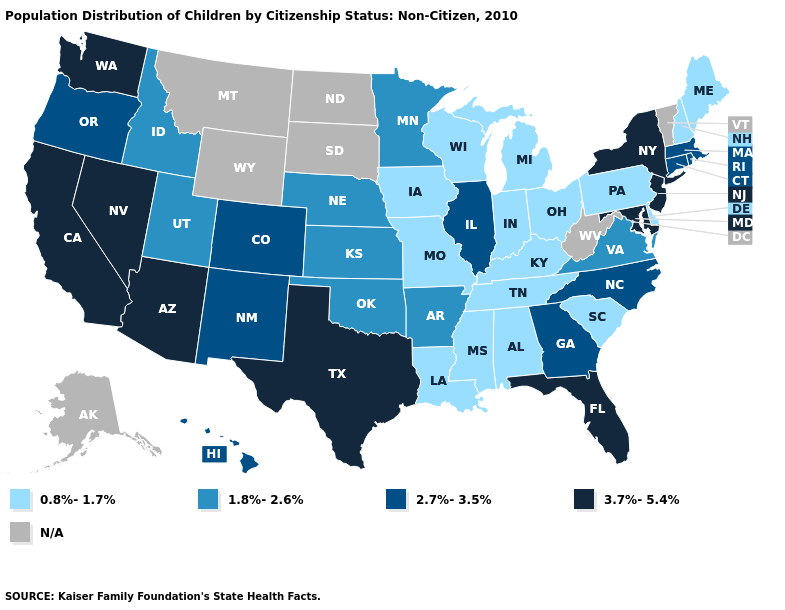Which states have the highest value in the USA?
Write a very short answer. Arizona, California, Florida, Maryland, Nevada, New Jersey, New York, Texas, Washington. What is the lowest value in the USA?
Be succinct. 0.8%-1.7%. What is the value of New Mexico?
Write a very short answer. 2.7%-3.5%. Which states hav the highest value in the West?
Quick response, please. Arizona, California, Nevada, Washington. Does New Hampshire have the lowest value in the USA?
Write a very short answer. Yes. What is the lowest value in the MidWest?
Give a very brief answer. 0.8%-1.7%. Among the states that border New Mexico , does Texas have the highest value?
Write a very short answer. Yes. How many symbols are there in the legend?
Keep it brief. 5. What is the lowest value in the USA?
Quick response, please. 0.8%-1.7%. What is the lowest value in states that border New Mexico?
Be succinct. 1.8%-2.6%. Name the states that have a value in the range 0.8%-1.7%?
Give a very brief answer. Alabama, Delaware, Indiana, Iowa, Kentucky, Louisiana, Maine, Michigan, Mississippi, Missouri, New Hampshire, Ohio, Pennsylvania, South Carolina, Tennessee, Wisconsin. Among the states that border New Hampshire , does Massachusetts have the highest value?
Give a very brief answer. Yes. Name the states that have a value in the range 1.8%-2.6%?
Write a very short answer. Arkansas, Idaho, Kansas, Minnesota, Nebraska, Oklahoma, Utah, Virginia. 